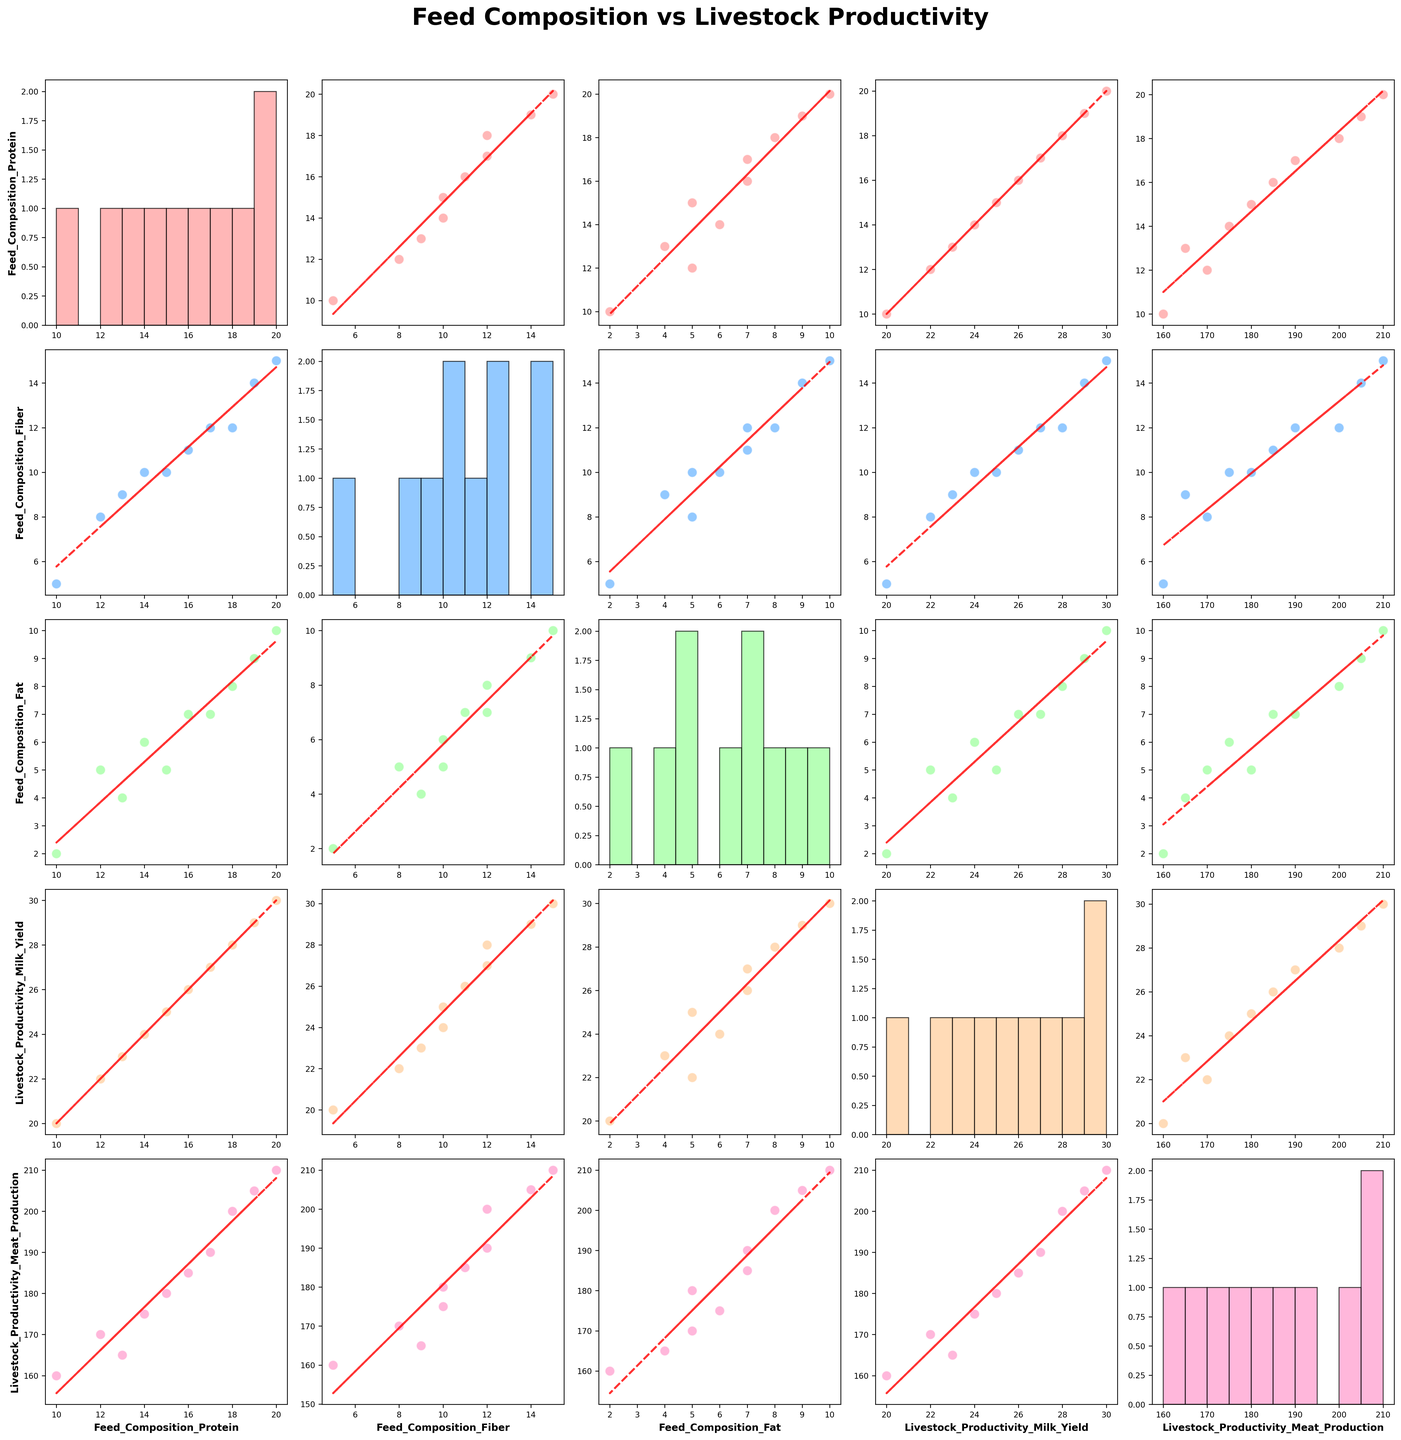What is the title of the figure? The title is located at the top center of the figure. It reads "Feed Composition vs Livestock Productivity."
Answer: Feed Composition vs Livestock Productivity How many variables are being compared in the SPLOM? The variables are along the axes of the SPLOM. The variables are Feed_Composition_Protein, Feed_Composition_Fiber, Feed_Composition_Fat, Livestock_Productivity_Milk_Yield, and Livestock_Productivity_Meat_Production.
Answer: 5 How many data points are in each scatter plot? Looking at the scatter plots, each involves plotting the 10 data points, as provided by the data summary.
Answer: 10 Which variable has the highest maximum value in the histograms along the diagonal? By examining the histograms along the diagonal, Livestock_Productivity_Meat_Production has the highest maximum value of 210.
Answer: Livestock_Productivity_Meat_Production Does Feed_Composition_Protein show a positive or negative trend with Livestock_Productivity_Milk_Yield? The scatter plot between Feed_Composition_Protein and Livestock_Productivity_Milk_Yield shows a positive trend as indicated by the rising red trend line.
Answer: Positive Is there any pair of variables that do not show a clear trend in their scatter plot? By visually inspecting each scatter plot, the relation between Feed_Composition_Fat and Livestock_Productivity_Meat_Production does not show a clear trend.
Answer: Feed_Composition_Fat and Livestock_Productivity_Meat_Production Which variable has the most data points in the lower range (0-10) based on the histograms? Feed_Composition_Fiber has the most data points in the lower range (0-10) as seen in its histogram.
Answer: Feed_Composition_Fiber Are there any variables that have overlapping data ranges in their scatter plots? Feed_Composition_Protein and Livestock_Productivity_Milk_Yield show overlapping ranges when compared with each other in their scatter plots.
Answer: Yes Between Feed_Composition_Protein and Feed_Composition_Fat, which has a higher average based on their histograms? By summing the midpoints and comparing the histograms, Feed_Composition_Protein has higher average values than Feed_Composition_Fat.
Answer: Feed_Composition_Protein 